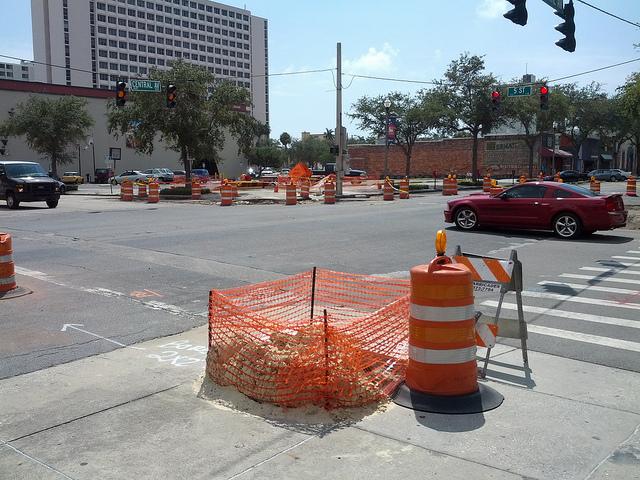What does the barrel indicate?
Write a very short answer. Caution. What color is the barrel?
Concise answer only. Orange. Are there any workers on the street?
Keep it brief. No. 